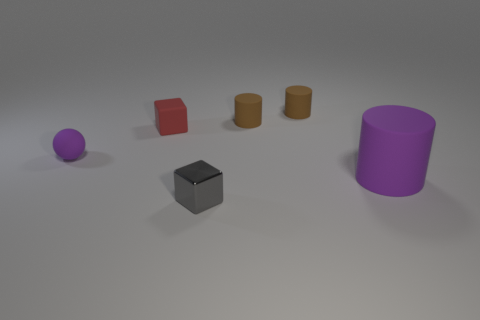Can you describe the texture of the objects in the image? While it's difficult to determine texture from a visual standpoint, the objects appear to have relatively smooth surfaces, with some having a slight glossiness. The purple sphere, for instance, has a subtle reflective quality, while the cylinders and cube appear more matte. However, any perceived texture is primarily an interpretation of visual cues, as actual texture would require tactile feedback to accurately assess. 